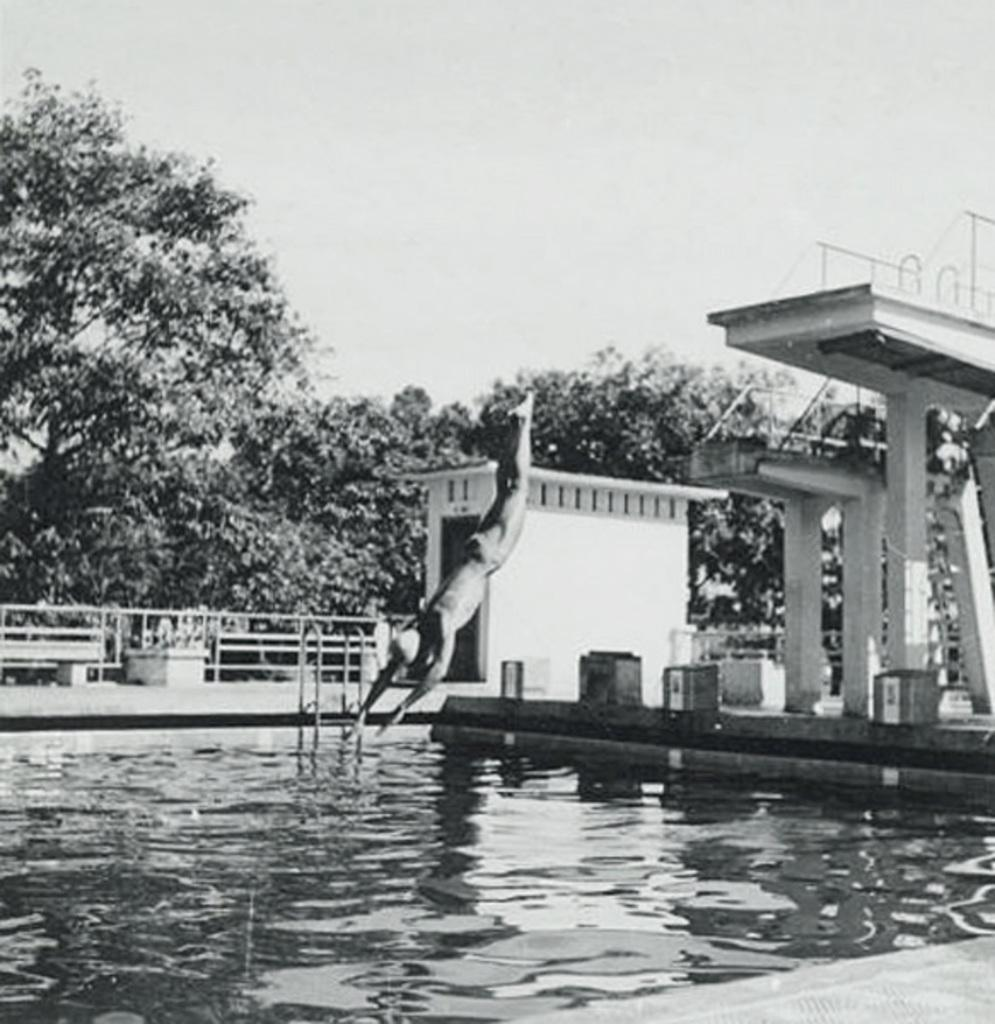What is the person in the image doing? The person is in the air, which suggests they might be flying or jumping. What is located near the person in the image? There is a swimming pool and a building in the image. What type of vegetation is present in the image? There are trees in the image. How is the image presented in terms of color? The image is in black and white. What type of park can be seen in the image? There is no park present in the image. What color is the gold object in the image? There is no gold object present in the image. 